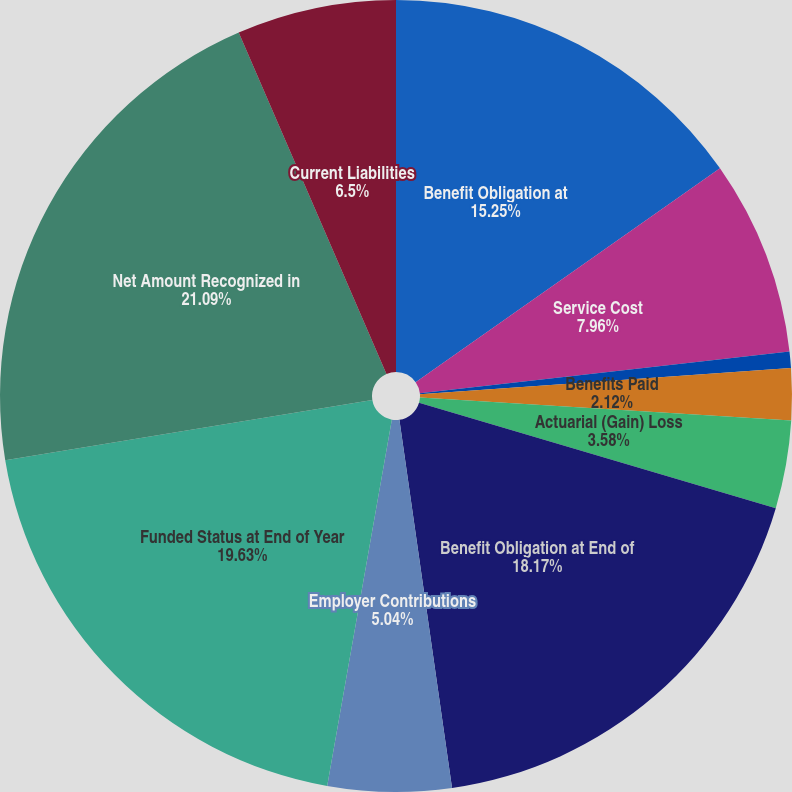Convert chart to OTSL. <chart><loc_0><loc_0><loc_500><loc_500><pie_chart><fcel>Benefit Obligation at<fcel>Service Cost<fcel>Interest Cost<fcel>Benefits Paid<fcel>Actuarial (Gain) Loss<fcel>Benefit Obligation at End of<fcel>Employer Contributions<fcel>Funded Status at End of Year<fcel>Net Amount Recognized in<fcel>Current Liabilities<nl><fcel>15.25%<fcel>7.96%<fcel>0.66%<fcel>2.12%<fcel>3.58%<fcel>18.17%<fcel>5.04%<fcel>19.63%<fcel>21.09%<fcel>6.5%<nl></chart> 